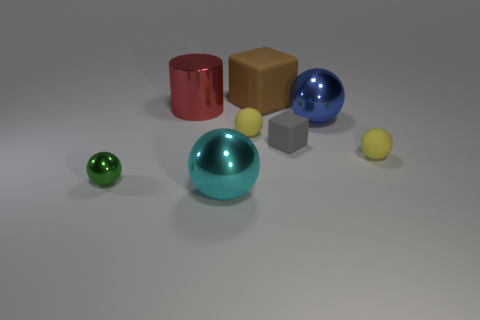Subtract all large cyan balls. How many balls are left? 4 Subtract all cyan spheres. How many spheres are left? 4 Subtract all brown spheres. Subtract all red cylinders. How many spheres are left? 5 Add 1 cyan shiny balls. How many objects exist? 9 Subtract all balls. How many objects are left? 3 Subtract all big gray cylinders. Subtract all blue metal things. How many objects are left? 7 Add 2 gray blocks. How many gray blocks are left? 3 Add 6 large cyan things. How many large cyan things exist? 7 Subtract 0 blue cylinders. How many objects are left? 8 